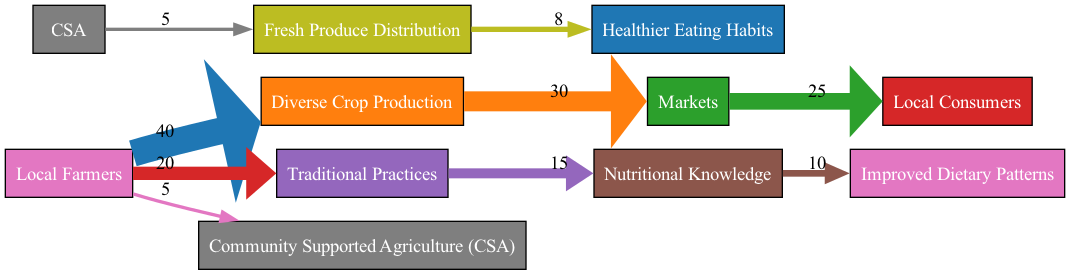What is the total flow from Local Farmers to Diverse Crop Production? The flow from Local Farmers to Diverse Crop Production is depicted in the diagram as 40.
Answer: 40 How many nodes are present in the diagram? By counting the distinct entities in the flow, we identify a total of 8 nodes: Local Farmers, Diverse Crop Production, Markets, Local Consumers, Traditional Practices, Nutritional Knowledge, Improved Dietary Patterns, Community Supported Agriculture, and Fresh Produce Distribution.
Answer: 8 What is the flow from Diverse Crop Production to Markets? The diagram specifically indicates that the flow from Diverse Crop Production to Markets is 30.
Answer: 30 What is the total flow from Local Farmers to the final outcome of Healthier Eating Habits? To get the flow to Healthier Eating Habits, we examine the flow paths. First, from Local Farmers to CSA (5), then from CSA to Fresh Produce Distribution (5), and finally from Fresh Produce Distribution to Healthier Eating Habits (8). Adding these, we get 5 + 5 + 8 = 18.
Answer: 18 Which pathway has the highest single flow value in the diagram? The highest single flow value is the path from Local Farmers to Diverse Crop Production, which is 40.
Answer: 40 How much flow is directed from Traditional Practices to Nutritional Knowledge? The diagram indicates the flow from Traditional Practices to Nutritional Knowledge is 15.
Answer: 15 What is the combined flow from Fresh Produce Distribution to Healthier Eating Habits? The flow from Fresh Produce Distribution to Healthier Eating Habits is directly represented as 8. There is no additional flow to consider.
Answer: 8 Which two nodes show a flow of 5? The nodes Community Supported Agriculture and Fresh Produce Distribution both show a flow of 5 connecting them.
Answer: Community Supported Agriculture and Fresh Produce Distribution What is the total flow value from Markets to Local Consumers? The diagram shows that the flow value from Markets to Local Consumers is 25.
Answer: 25 